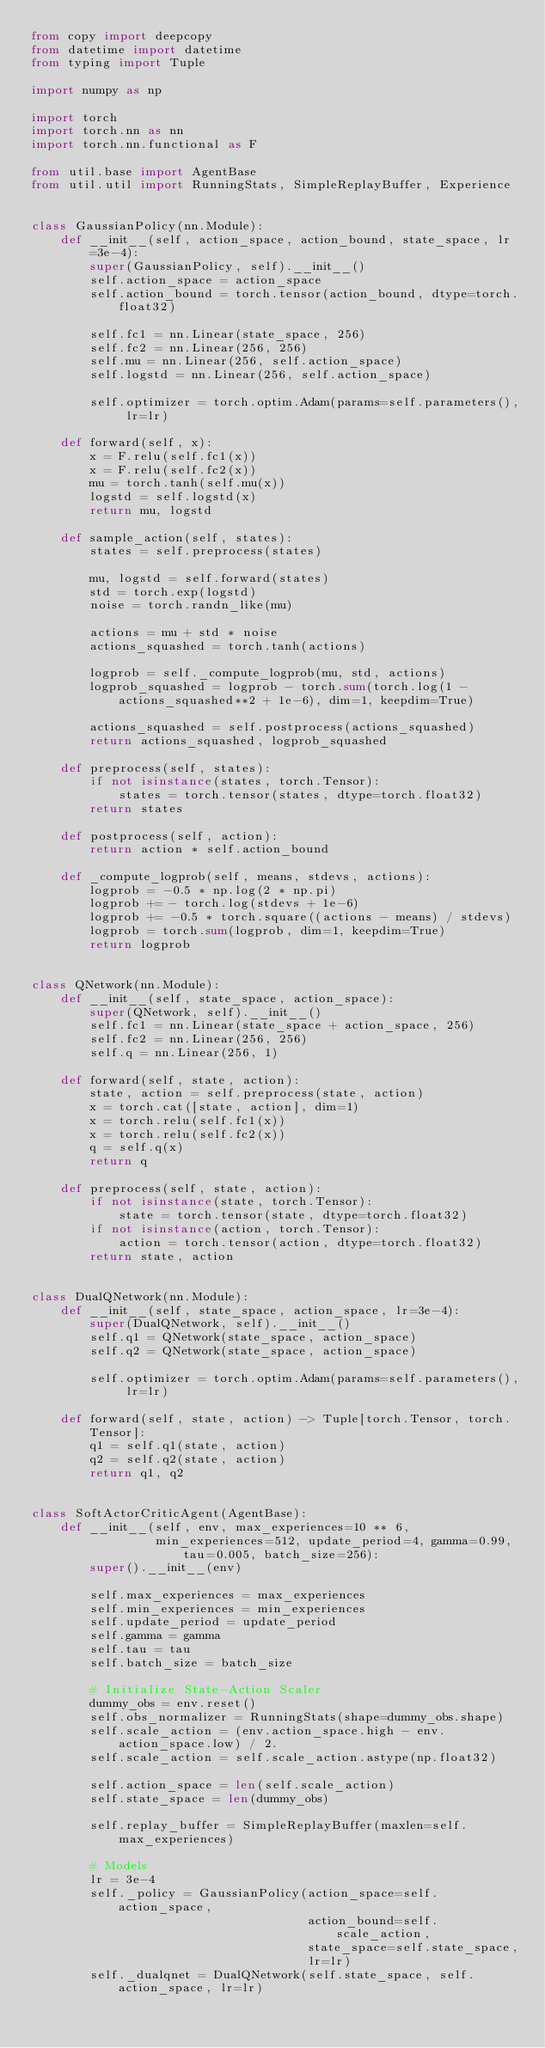Convert code to text. <code><loc_0><loc_0><loc_500><loc_500><_Python_>from copy import deepcopy
from datetime import datetime
from typing import Tuple

import numpy as np

import torch
import torch.nn as nn
import torch.nn.functional as F

from util.base import AgentBase
from util.util import RunningStats, SimpleReplayBuffer, Experience


class GaussianPolicy(nn.Module):
    def __init__(self, action_space, action_bound, state_space, lr=3e-4):
        super(GaussianPolicy, self).__init__()
        self.action_space = action_space
        self.action_bound = torch.tensor(action_bound, dtype=torch.float32)

        self.fc1 = nn.Linear(state_space, 256)
        self.fc2 = nn.Linear(256, 256)
        self.mu = nn.Linear(256, self.action_space)
        self.logstd = nn.Linear(256, self.action_space)

        self.optimizer = torch.optim.Adam(params=self.parameters(), lr=lr)

    def forward(self, x):
        x = F.relu(self.fc1(x))
        x = F.relu(self.fc2(x))
        mu = torch.tanh(self.mu(x))
        logstd = self.logstd(x)
        return mu, logstd

    def sample_action(self, states):
        states = self.preprocess(states)

        mu, logstd = self.forward(states)
        std = torch.exp(logstd)
        noise = torch.randn_like(mu)

        actions = mu + std * noise
        actions_squashed = torch.tanh(actions)

        logprob = self._compute_logprob(mu, std, actions)
        logprob_squashed = logprob - torch.sum(torch.log(1 - actions_squashed**2 + 1e-6), dim=1, keepdim=True)

        actions_squashed = self.postprocess(actions_squashed)
        return actions_squashed, logprob_squashed

    def preprocess(self, states):
        if not isinstance(states, torch.Tensor):
            states = torch.tensor(states, dtype=torch.float32)
        return states

    def postprocess(self, action):
        return action * self.action_bound

    def _compute_logprob(self, means, stdevs, actions):
        logprob = -0.5 * np.log(2 * np.pi)
        logprob += - torch.log(stdevs + 1e-6)
        logprob += -0.5 * torch.square((actions - means) / stdevs)
        logprob = torch.sum(logprob, dim=1, keepdim=True)
        return logprob


class QNetwork(nn.Module):
    def __init__(self, state_space, action_space):
        super(QNetwork, self).__init__()
        self.fc1 = nn.Linear(state_space + action_space, 256)
        self.fc2 = nn.Linear(256, 256)
        self.q = nn.Linear(256, 1)

    def forward(self, state, action):
        state, action = self.preprocess(state, action)
        x = torch.cat([state, action], dim=1)
        x = torch.relu(self.fc1(x))
        x = torch.relu(self.fc2(x))
        q = self.q(x)
        return q

    def preprocess(self, state, action):
        if not isinstance(state, torch.Tensor):
            state = torch.tensor(state, dtype=torch.float32)
        if not isinstance(action, torch.Tensor):
            action = torch.tensor(action, dtype=torch.float32)
        return state, action


class DualQNetwork(nn.Module):
    def __init__(self, state_space, action_space, lr=3e-4):
        super(DualQNetwork, self).__init__()
        self.q1 = QNetwork(state_space, action_space)
        self.q2 = QNetwork(state_space, action_space)

        self.optimizer = torch.optim.Adam(params=self.parameters(), lr=lr)

    def forward(self, state, action) -> Tuple[torch.Tensor, torch.Tensor]:
        q1 = self.q1(state, action)
        q2 = self.q2(state, action)
        return q1, q2


class SoftActorCriticAgent(AgentBase):
    def __init__(self, env, max_experiences=10 ** 6,
                 min_experiences=512, update_period=4, gamma=0.99, tau=0.005, batch_size=256):
        super().__init__(env)

        self.max_experiences = max_experiences
        self.min_experiences = min_experiences
        self.update_period = update_period
        self.gamma = gamma
        self.tau = tau
        self.batch_size = batch_size

        # Initialize State-Action Scaler
        dummy_obs = env.reset()
        self.obs_normalizer = RunningStats(shape=dummy_obs.shape)
        self.scale_action = (env.action_space.high - env.action_space.low) / 2.
        self.scale_action = self.scale_action.astype(np.float32)

        self.action_space = len(self.scale_action)
        self.state_space = len(dummy_obs)

        self.replay_buffer = SimpleReplayBuffer(maxlen=self.max_experiences)

        # Models
        lr = 3e-4
        self._policy = GaussianPolicy(action_space=self.action_space,
                                      action_bound=self.scale_action,
                                      state_space=self.state_space,
                                      lr=lr)
        self._dualqnet = DualQNetwork(self.state_space, self.action_space, lr=lr)</code> 